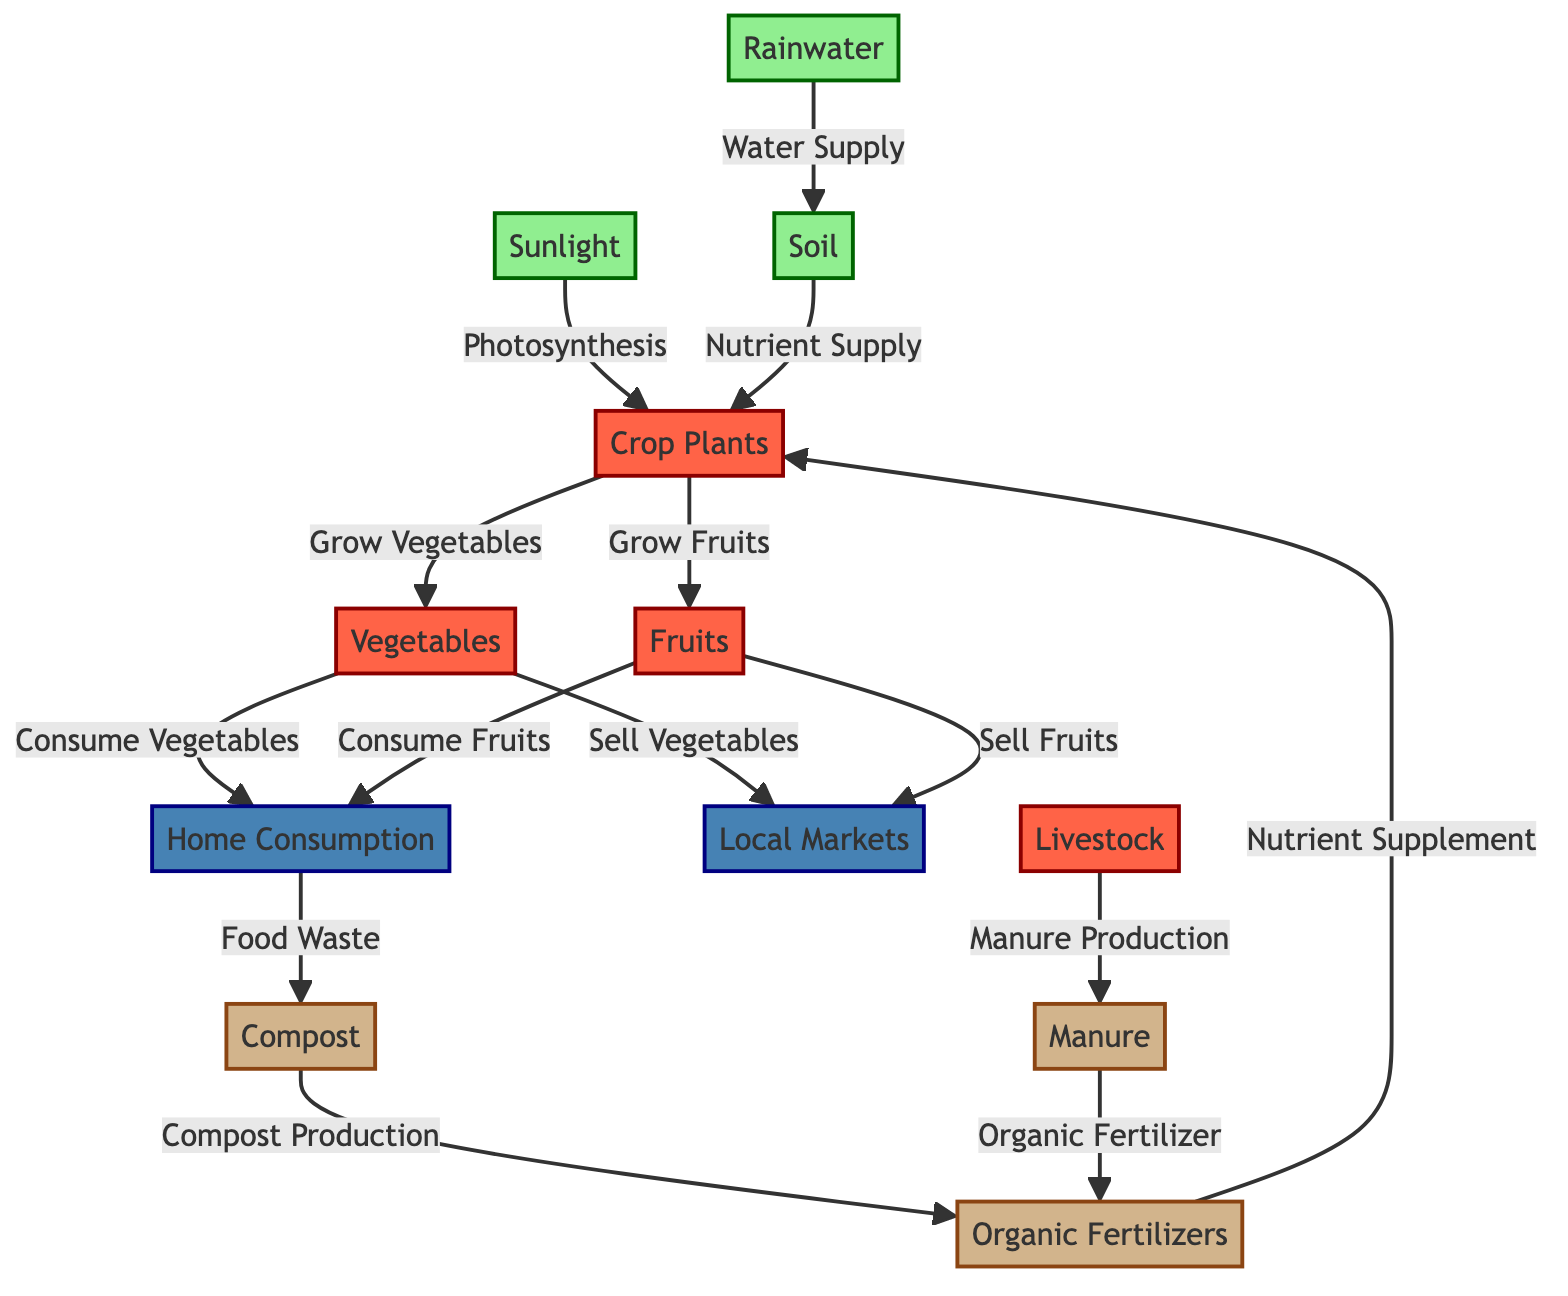What are the natural resources in the diagram? The diagram lists sunlight, rainwater, and soil as the natural resources. These are identified by the nodes that have the class 'naturalResource', which color-codes them for easy identification.
Answer: sunlight, rainwater, soil How many organic materials are used for crop growth? The diagram shows organic fertilizers, compost, and manure as organic materials contributing to crop growth. By identifying nodes classified as 'organicMatter', we find three distinct items.
Answer: 3 What do crop plants produce? The crop plants in the diagram produce both vegetables and fruits. The relationships leading from the crop plants node show these two outputs distinctly labeled.
Answer: vegetables and fruits Where do vegetables and fruits go after production? According to the diagram, vegetables and fruits are sold in local markets and can also be consumed at home. This is derived from following the arrows leading from the vegetables and fruits nodes to their respective outcomes.
Answer: local markets and home consumption What role does compost play in the food chain? Compost production serves as a nutrient supply for the organic fertilizers and also contributes to soil health. By examining the connections between the compost node and others, we can see its dual role in enhancing fertility and sustainability.
Answer: Nutrient Supply Which nodes represent home consumption? The home consumption is represented by the node labeled "Home Consumption," where both vegetables and fruits can be consumed, resulting in food waste as shown further down the diagram. The identification is based on the placement in the diagram.
Answer: Home Consumption What results from the consumption of fruits and vegetables? The consumption of fruits and vegetables leads to food waste, as indicated by the arrows from the fruits and vegetables nodes, which point towards the node for home consumption and ultimately to the food waste.
Answer: Food Waste How does livestock contribute to organic farming? Livestock contributes by producing manure, which is then used to create organic fertilizers. This direct flow between livestock to manure and further to organic fertilizer indicates the role of livestock in maintaining soil health naturally.
Answer: Manure Production 